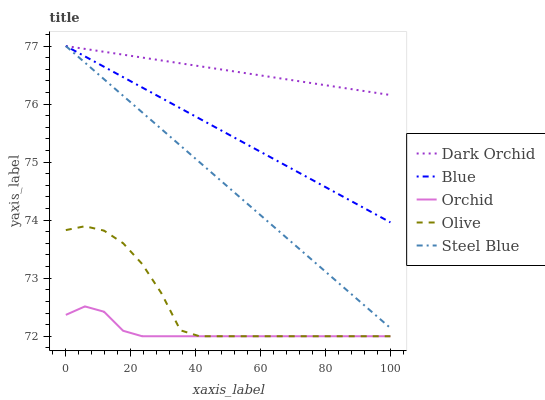Does Orchid have the minimum area under the curve?
Answer yes or no. Yes. Does Dark Orchid have the maximum area under the curve?
Answer yes or no. Yes. Does Olive have the minimum area under the curve?
Answer yes or no. No. Does Olive have the maximum area under the curve?
Answer yes or no. No. Is Steel Blue the smoothest?
Answer yes or no. Yes. Is Olive the roughest?
Answer yes or no. Yes. Is Olive the smoothest?
Answer yes or no. No. Is Steel Blue the roughest?
Answer yes or no. No. Does Olive have the lowest value?
Answer yes or no. Yes. Does Steel Blue have the lowest value?
Answer yes or no. No. Does Dark Orchid have the highest value?
Answer yes or no. Yes. Does Olive have the highest value?
Answer yes or no. No. Is Orchid less than Dark Orchid?
Answer yes or no. Yes. Is Blue greater than Orchid?
Answer yes or no. Yes. Does Dark Orchid intersect Steel Blue?
Answer yes or no. Yes. Is Dark Orchid less than Steel Blue?
Answer yes or no. No. Is Dark Orchid greater than Steel Blue?
Answer yes or no. No. Does Orchid intersect Dark Orchid?
Answer yes or no. No. 